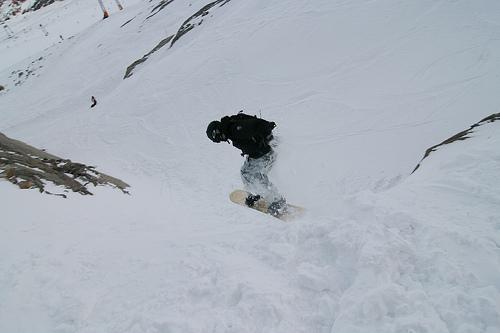How many snowboarders are there?
Give a very brief answer. 1. 